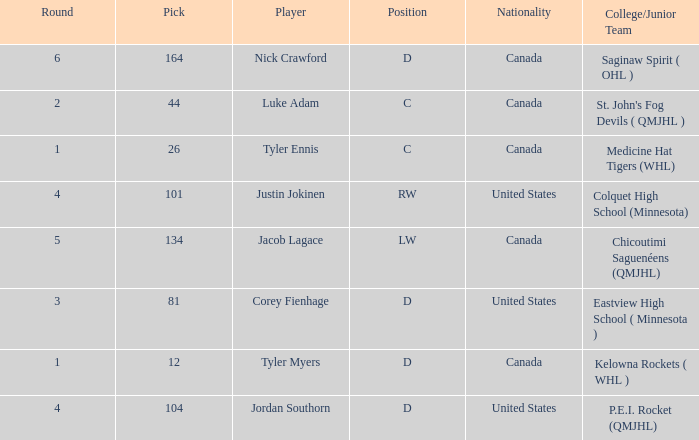What is the college/junior team of player tyler myers, who has a pick less than 44? Kelowna Rockets ( WHL ). 